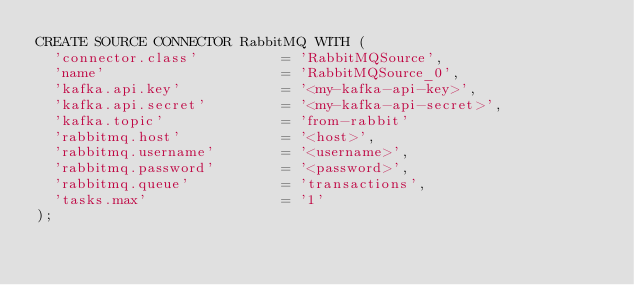Convert code to text. <code><loc_0><loc_0><loc_500><loc_500><_SQL_>CREATE SOURCE CONNECTOR RabbitMQ WITH (
  'connector.class'          = 'RabbitMQSource',
  'name'                     = 'RabbitMQSource_0',
  'kafka.api.key'            = '<my-kafka-api-key>',
  'kafka.api.secret'         = '<my-kafka-api-secret>',
  'kafka.topic'              = 'from-rabbit'
  'rabbitmq.host'            = '<host>',
  'rabbitmq.username'        = '<username>',
  'rabbitmq.password'        = '<password>',
  'rabbitmq.queue'           = 'transactions',
  'tasks.max'                = '1'
);
</code> 